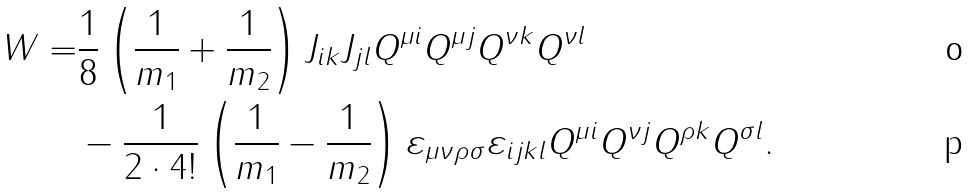Convert formula to latex. <formula><loc_0><loc_0><loc_500><loc_500>W = & \frac { 1 } { 8 } \left ( \frac { 1 } { m _ { 1 } } + \frac { 1 } { m _ { 2 } } \right ) J _ { i k } J _ { j l } Q ^ { \mu i } Q ^ { \mu j } Q ^ { \nu k } Q ^ { \nu l } \\ & - \frac { 1 } { 2 \cdot 4 ! } \left ( \frac { 1 } { m _ { 1 } } - \frac { 1 } { m _ { 2 } } \right ) \varepsilon _ { \mu \nu \rho \sigma } \varepsilon _ { i j k l } Q ^ { \mu i } Q ^ { \nu j } Q ^ { \rho k } Q ^ { \sigma l } .</formula> 